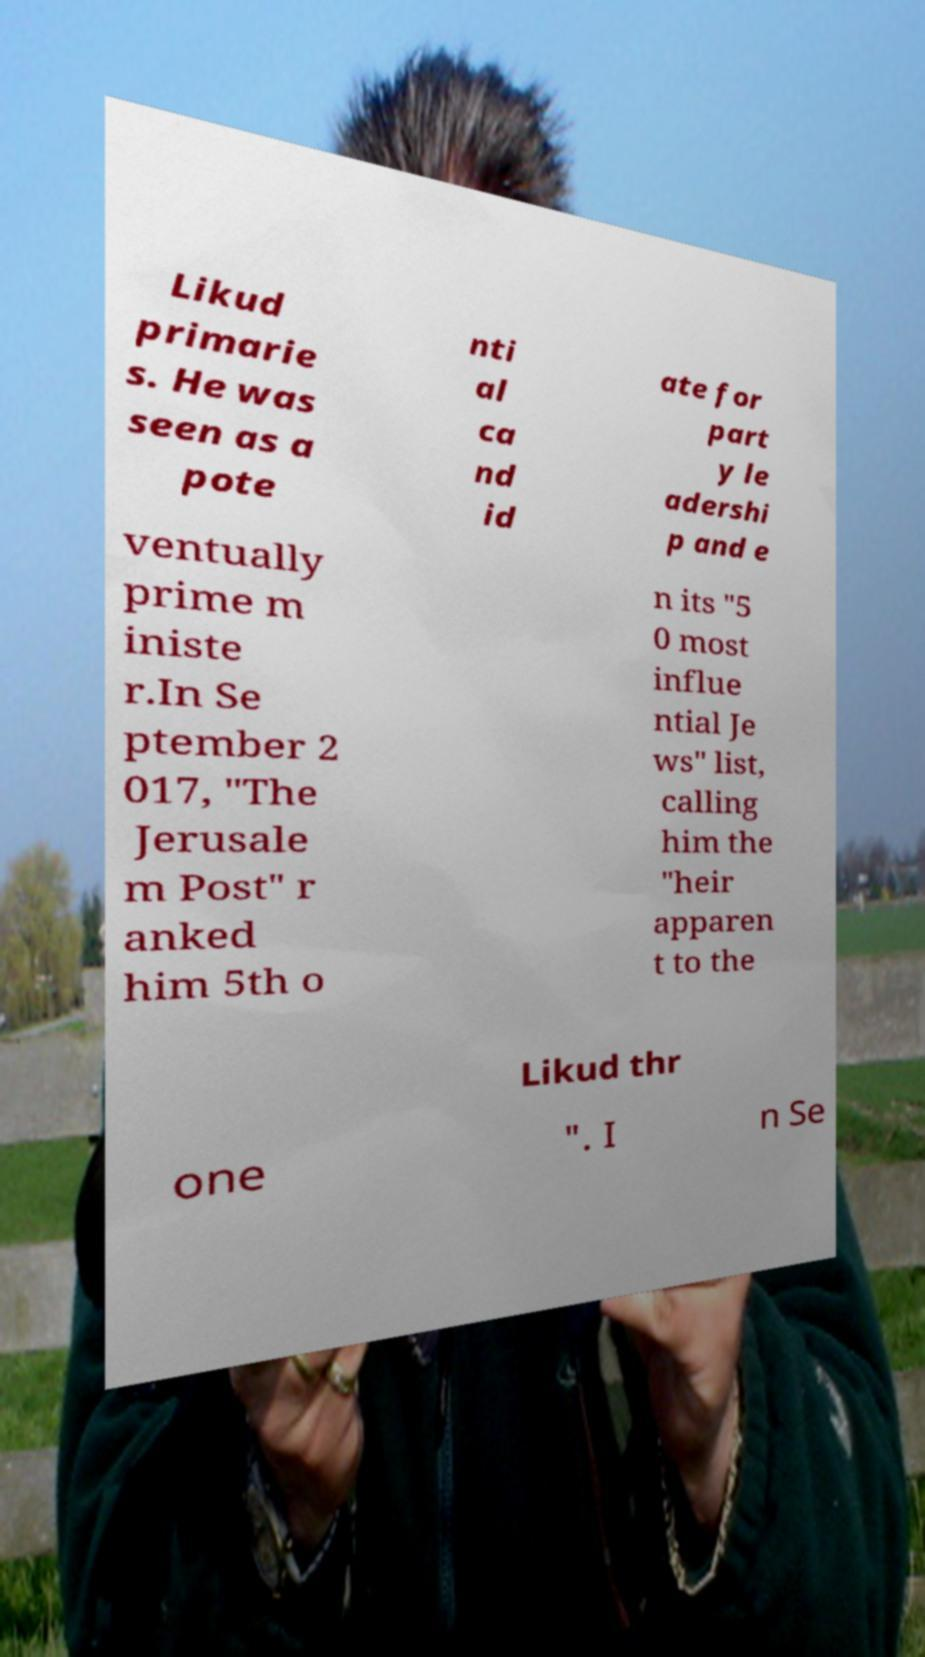Could you extract and type out the text from this image? Likud primarie s. He was seen as a pote nti al ca nd id ate for part y le adershi p and e ventually prime m iniste r.In Se ptember 2 017, "The Jerusale m Post" r anked him 5th o n its "5 0 most influe ntial Je ws" list, calling him the "heir apparen t to the Likud thr one ". I n Se 